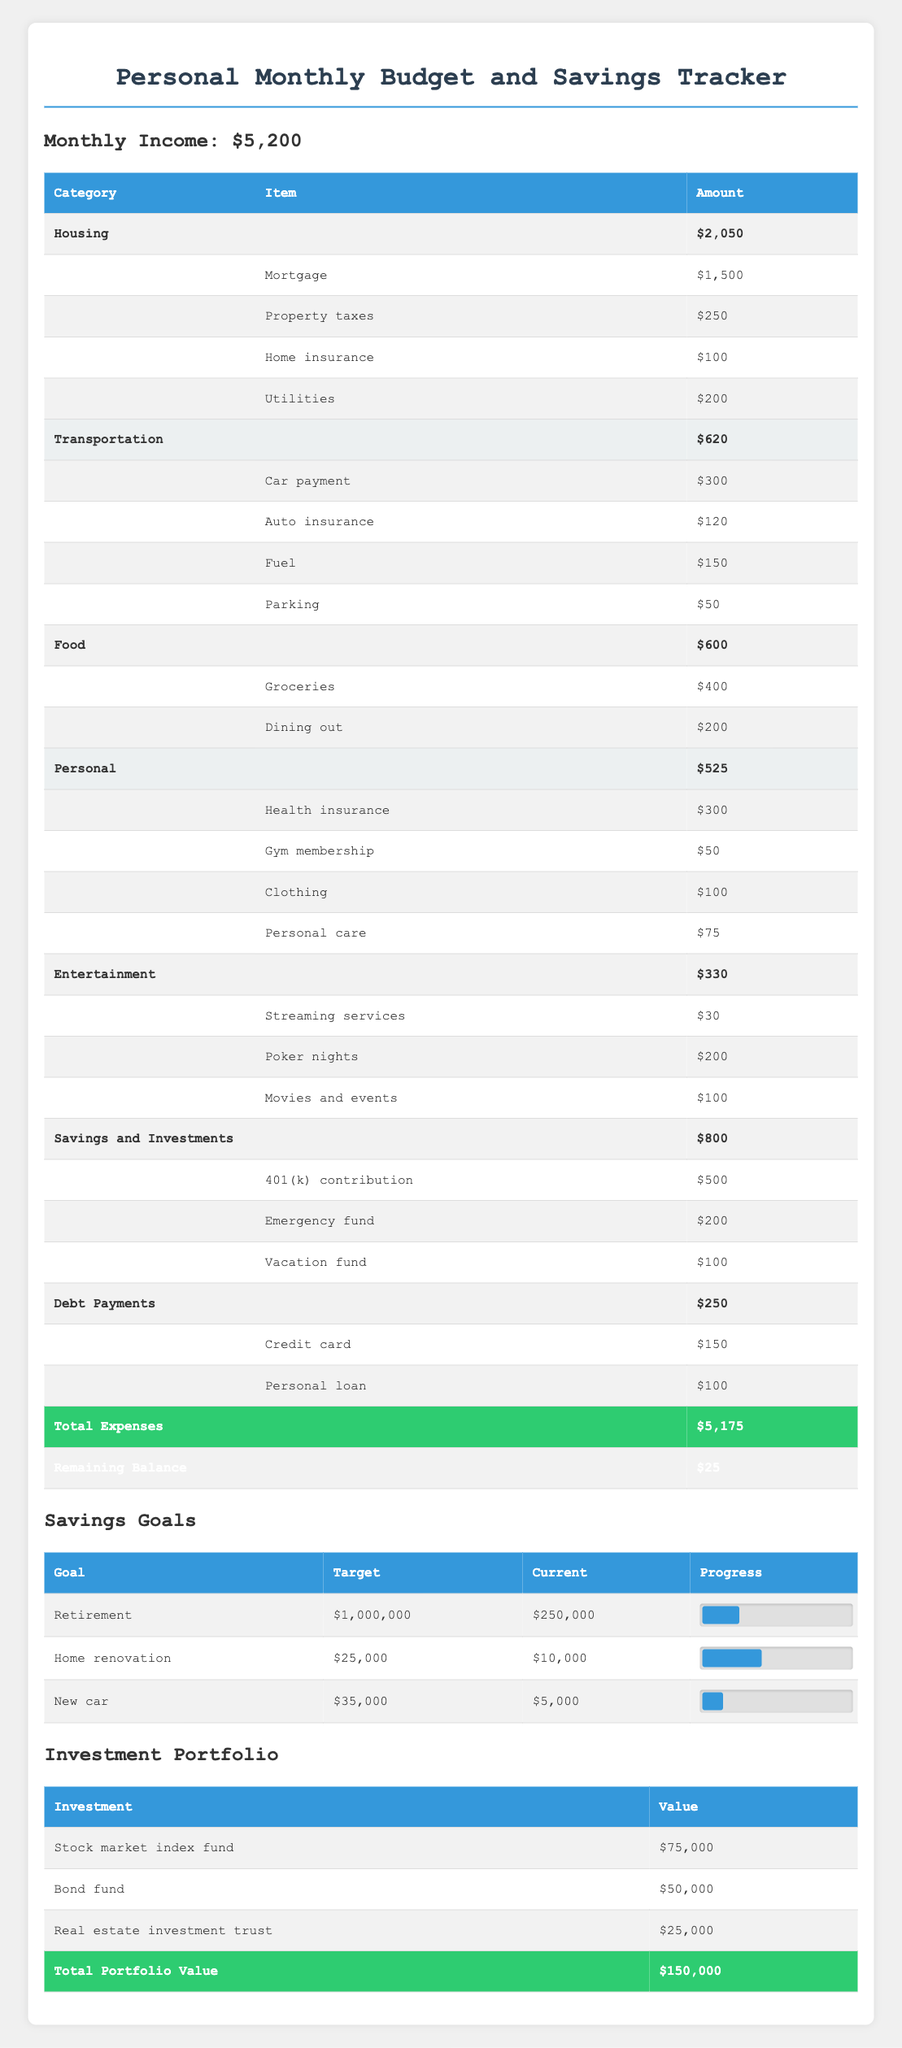What is the total amount spent on Housing? In the Housing category, the amounts are Mortgage ($1,500), Property taxes ($250), Home insurance ($100), and Utilities ($200). Adding these amounts gives a total of $1,500 + $250 + $100 + $200 = $2,050.
Answer: 2,050 How much is allocated to Savings and Investments? The Savings and Investments category shows three amounts: 401(k) contribution ($500), Emergency fund ($200), and Vacation fund ($100). Adding these amounts gives a total of $500 + $200 + $100 = $800.
Answer: 800 Is the monthly income greater than the total expenses? The monthly income is $5,200 and the total expenses are $5,175. Since $5,200 is greater than $5,175, the answer is yes.
Answer: Yes What is the total value of the investment portfolio? The investment portfolio consists of Stock market index fund ($75,000), Bond fund ($50,000), and Real estate investment trust ($25,000). Summing these values results in $75,000 + $50,000 + $25,000 = $150,000.
Answer: 150,000 How much has been spent on Transportation? In the Transportation category, the expenses are Car payment ($300), Auto insurance ($120), Fuel ($150), and Parking ($50). Summing these gives $300 + $120 + $150 + $50 = $620.
Answer: 620 What is the progress percentage towards the Retirement savings goal? The Retirement goal is $1,000,000, and the current savings is $250,000. The progress percentage is calculated as (250,000 / 1,000,000) * 100, which equals 25%.
Answer: 25% How much more is needed to reach the goal for Home renovation? The target for Home renovation is $25,000, and the current amount saved is $10,000. The amount still needed is calculated as $25,000 - $10,000 = $15,000.
Answer: 15,000 How much is spent on Poker nights compared to Streaming services? The expense for Poker nights is $200, and for Streaming services, it is $30. The difference in spending is $200 - $30 = $170.
Answer: 170 Is the amount in the Emergency fund greater than the amount allocated for personal care? The Emergency fund has $200 while personal care costs $75. Since $200 is greater than $75, the answer is yes.
Answer: Yes 